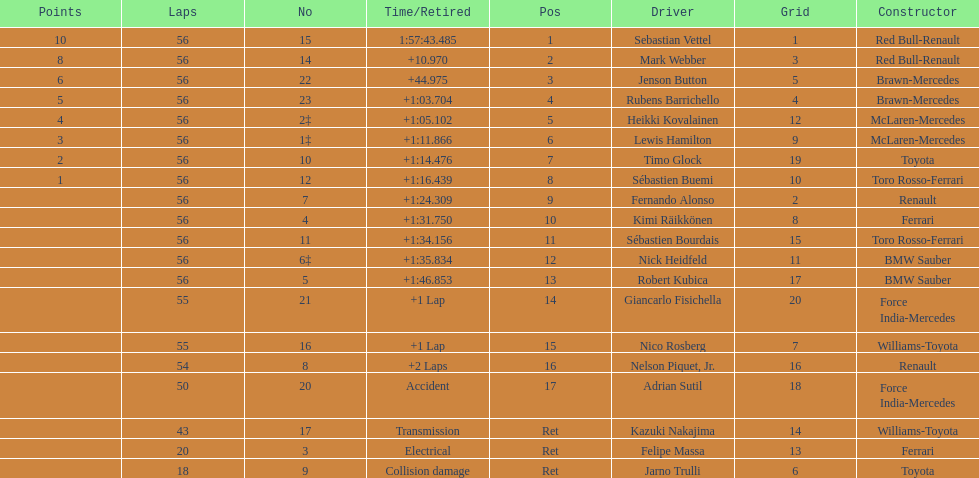What is the name of a driver that ferrari was not a constructor for? Sebastian Vettel. 